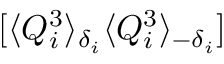<formula> <loc_0><loc_0><loc_500><loc_500>[ \langle Q _ { i } ^ { 3 } \rangle _ { \delta _ { i } } \langle Q _ { i } ^ { 3 } \rangle _ { - \delta _ { i } } ]</formula> 